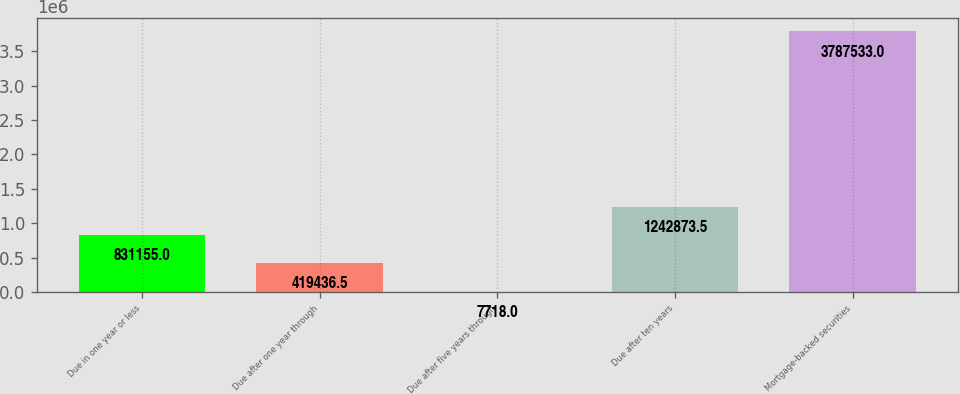Convert chart to OTSL. <chart><loc_0><loc_0><loc_500><loc_500><bar_chart><fcel>Due in one year or less<fcel>Due after one year through<fcel>Due after five years through<fcel>Due after ten years<fcel>Mortgage-backed securities<nl><fcel>831155<fcel>419436<fcel>7718<fcel>1.24287e+06<fcel>3.78753e+06<nl></chart> 